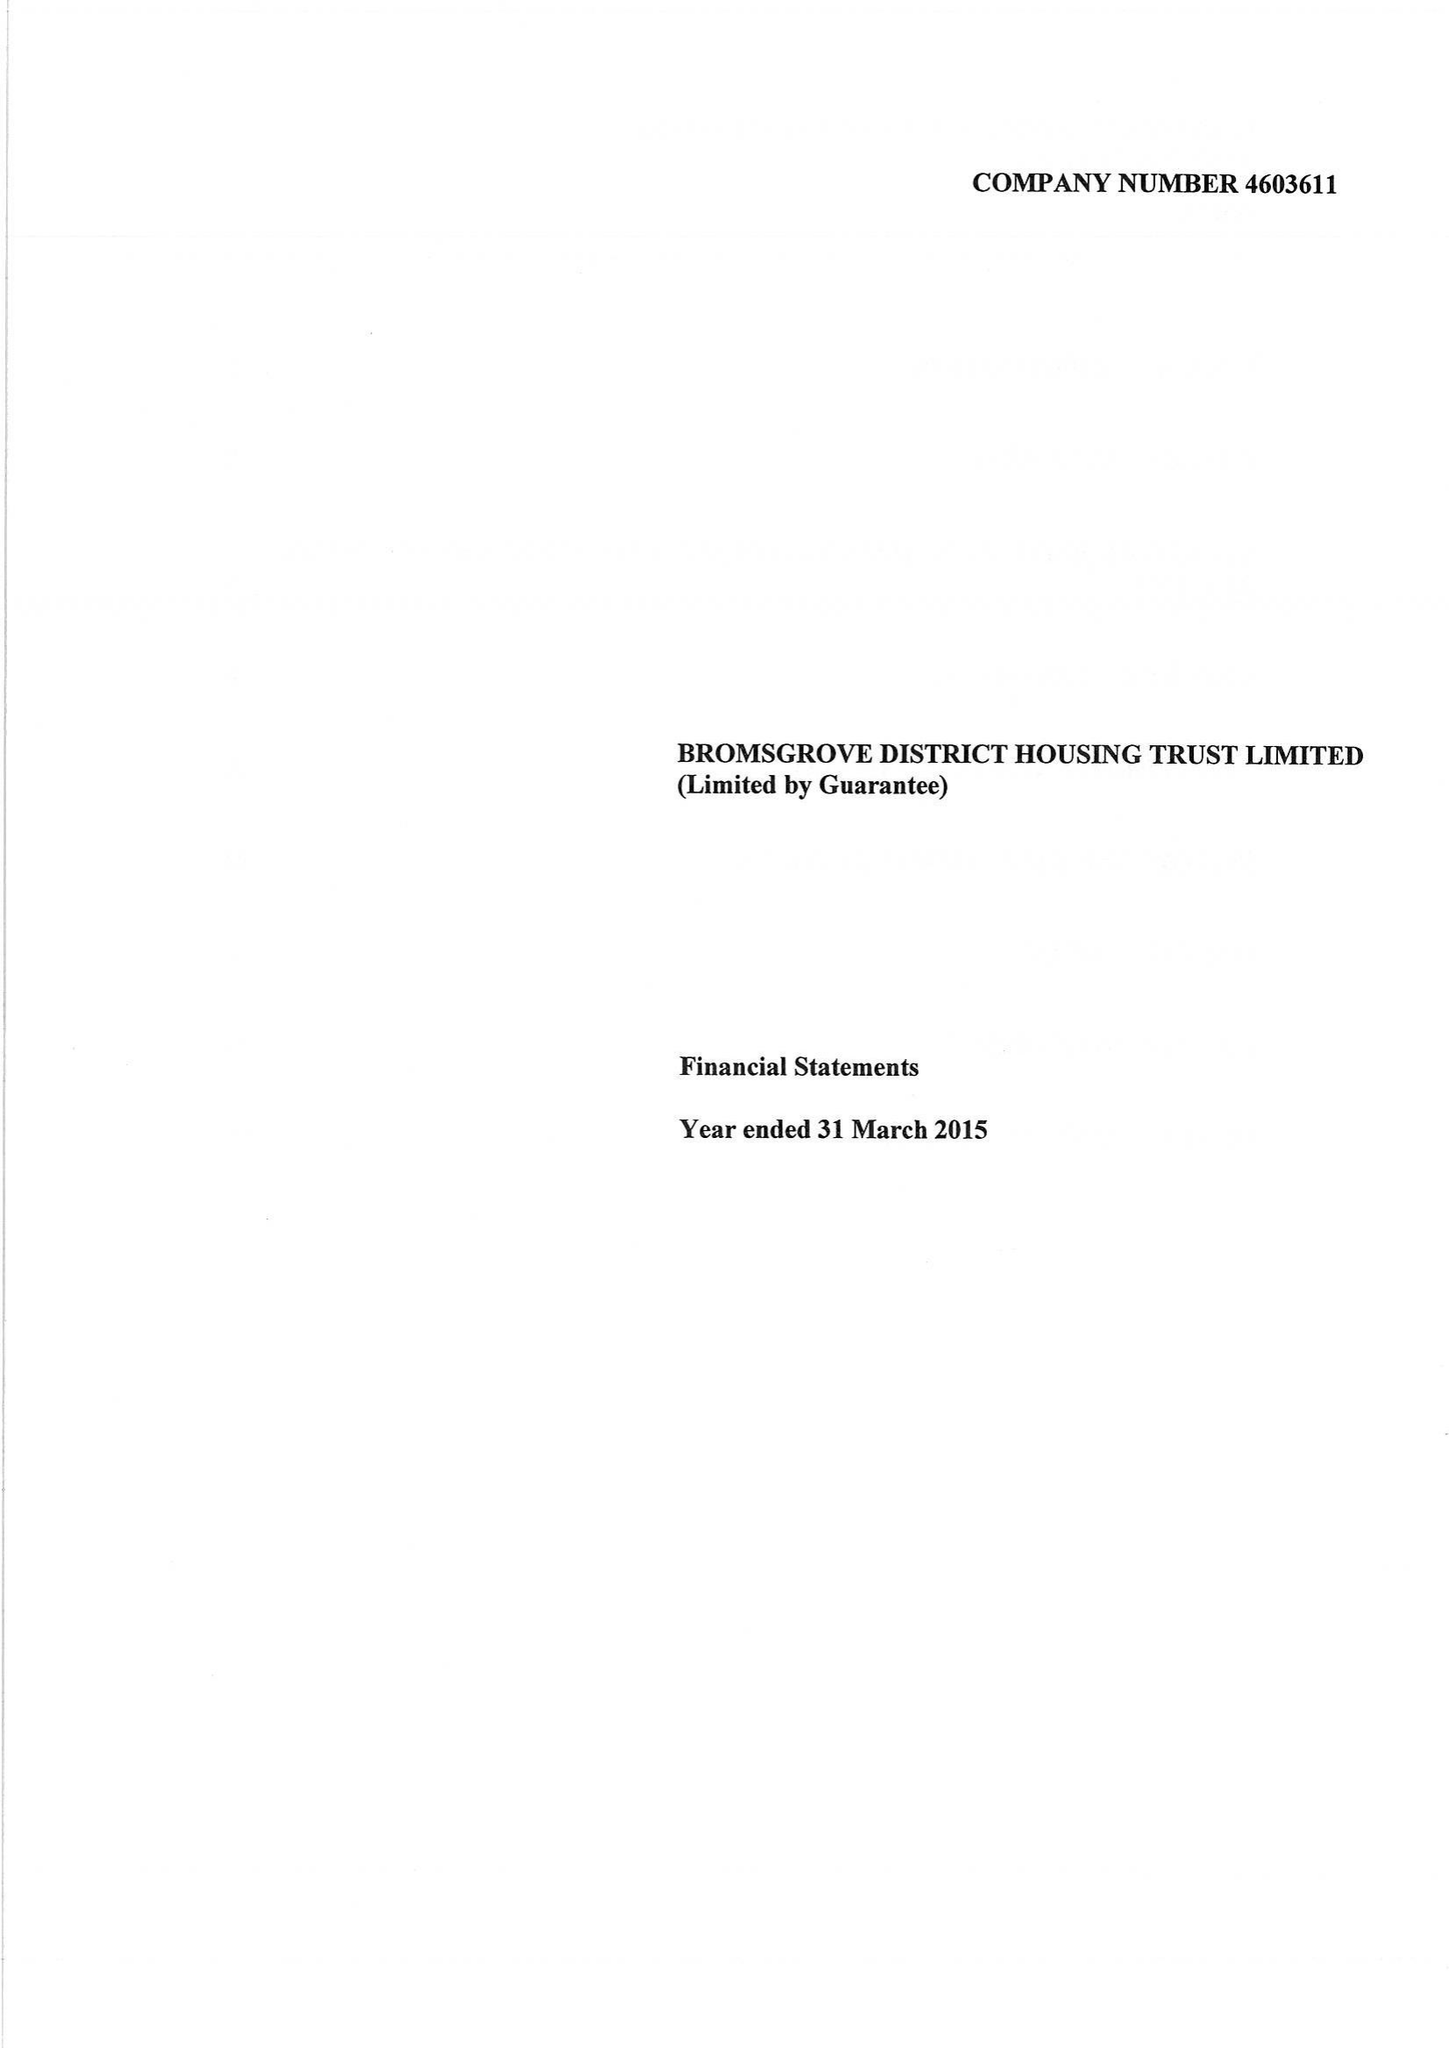What is the value for the income_annually_in_british_pounds?
Answer the question using a single word or phrase. 18253000.00 